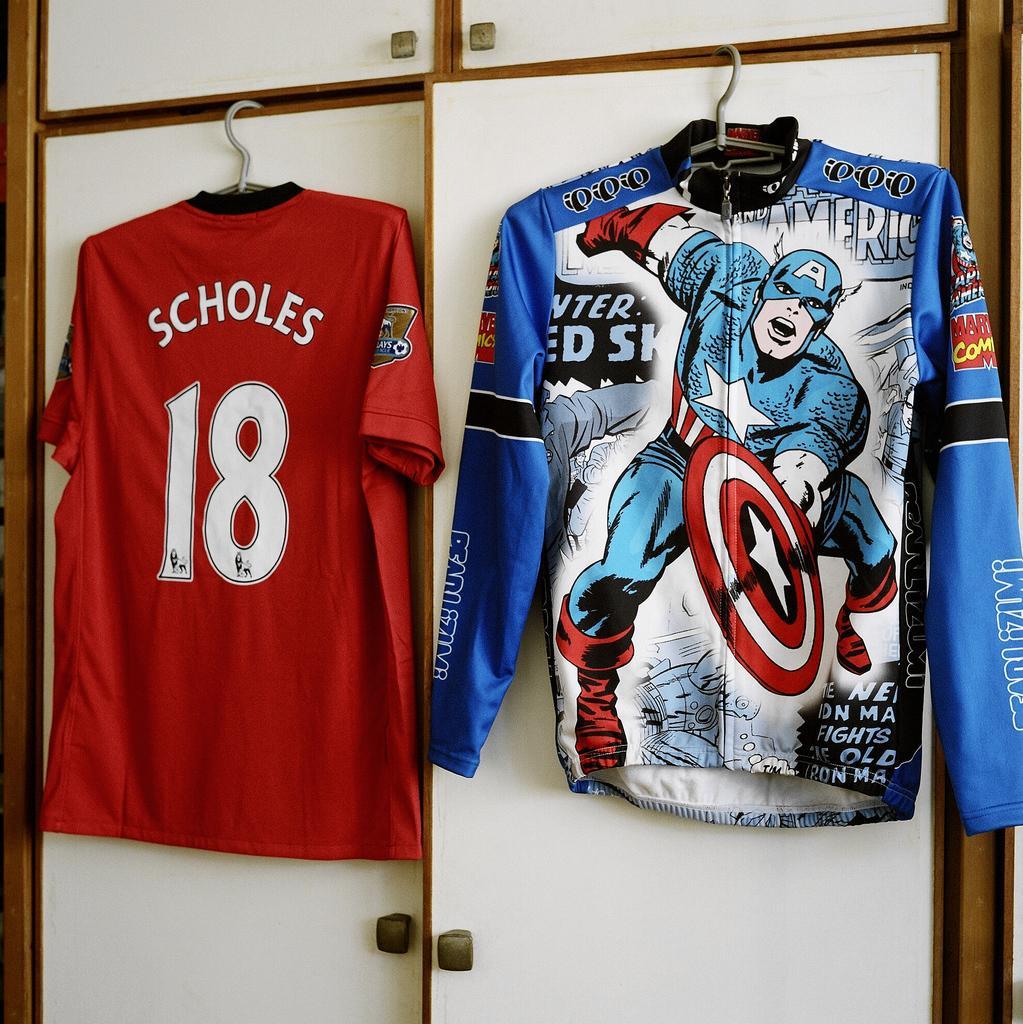Can you describe this image briefly? In the picture we can see a cupboard with two door and two T-shirts are hanged to it, one is red in color and one is blue in color with some cartoon paintings on it. 